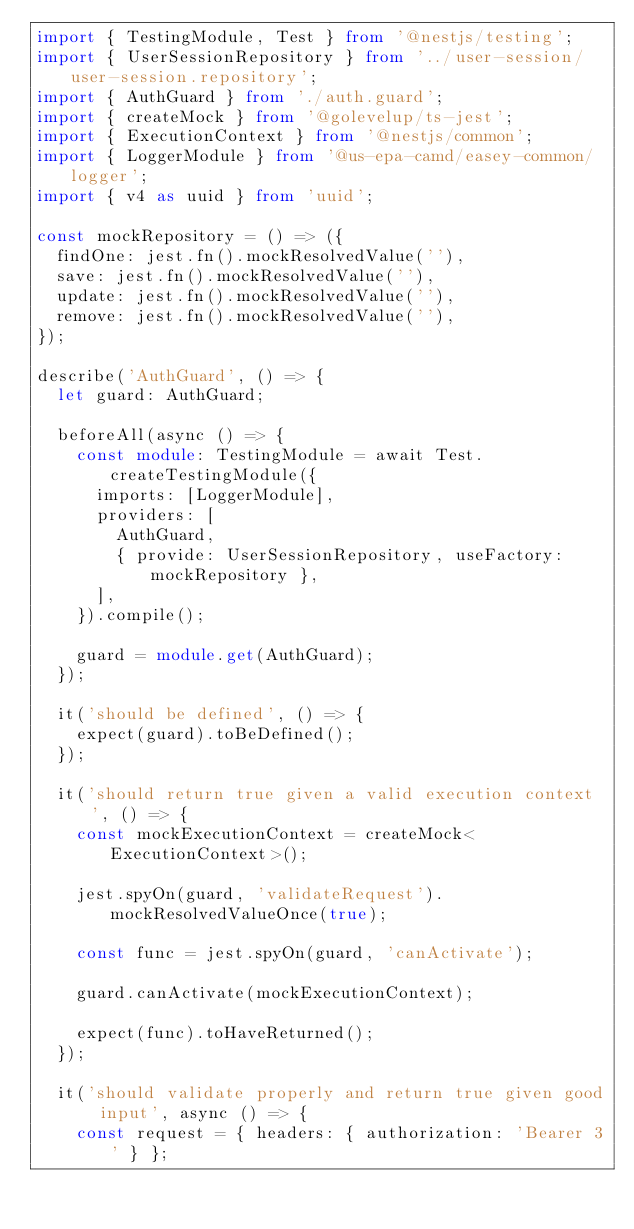Convert code to text. <code><loc_0><loc_0><loc_500><loc_500><_TypeScript_>import { TestingModule, Test } from '@nestjs/testing';
import { UserSessionRepository } from '../user-session/user-session.repository';
import { AuthGuard } from './auth.guard';
import { createMock } from '@golevelup/ts-jest';
import { ExecutionContext } from '@nestjs/common';
import { LoggerModule } from '@us-epa-camd/easey-common/logger';
import { v4 as uuid } from 'uuid';

const mockRepository = () => ({
  findOne: jest.fn().mockResolvedValue(''),
  save: jest.fn().mockResolvedValue(''),
  update: jest.fn().mockResolvedValue(''),
  remove: jest.fn().mockResolvedValue(''),
});

describe('AuthGuard', () => {
  let guard: AuthGuard;

  beforeAll(async () => {
    const module: TestingModule = await Test.createTestingModule({
      imports: [LoggerModule],
      providers: [
        AuthGuard,
        { provide: UserSessionRepository, useFactory: mockRepository },
      ],
    }).compile();

    guard = module.get(AuthGuard);
  });

  it('should be defined', () => {
    expect(guard).toBeDefined();
  });

  it('should return true given a valid execution context ', () => {
    const mockExecutionContext = createMock<ExecutionContext>();

    jest.spyOn(guard, 'validateRequest').mockResolvedValueOnce(true);

    const func = jest.spyOn(guard, 'canActivate');

    guard.canActivate(mockExecutionContext);

    expect(func).toHaveReturned();
  });

  it('should validate properly and return true given good input', async () => {
    const request = { headers: { authorization: 'Bearer 3' } };</code> 